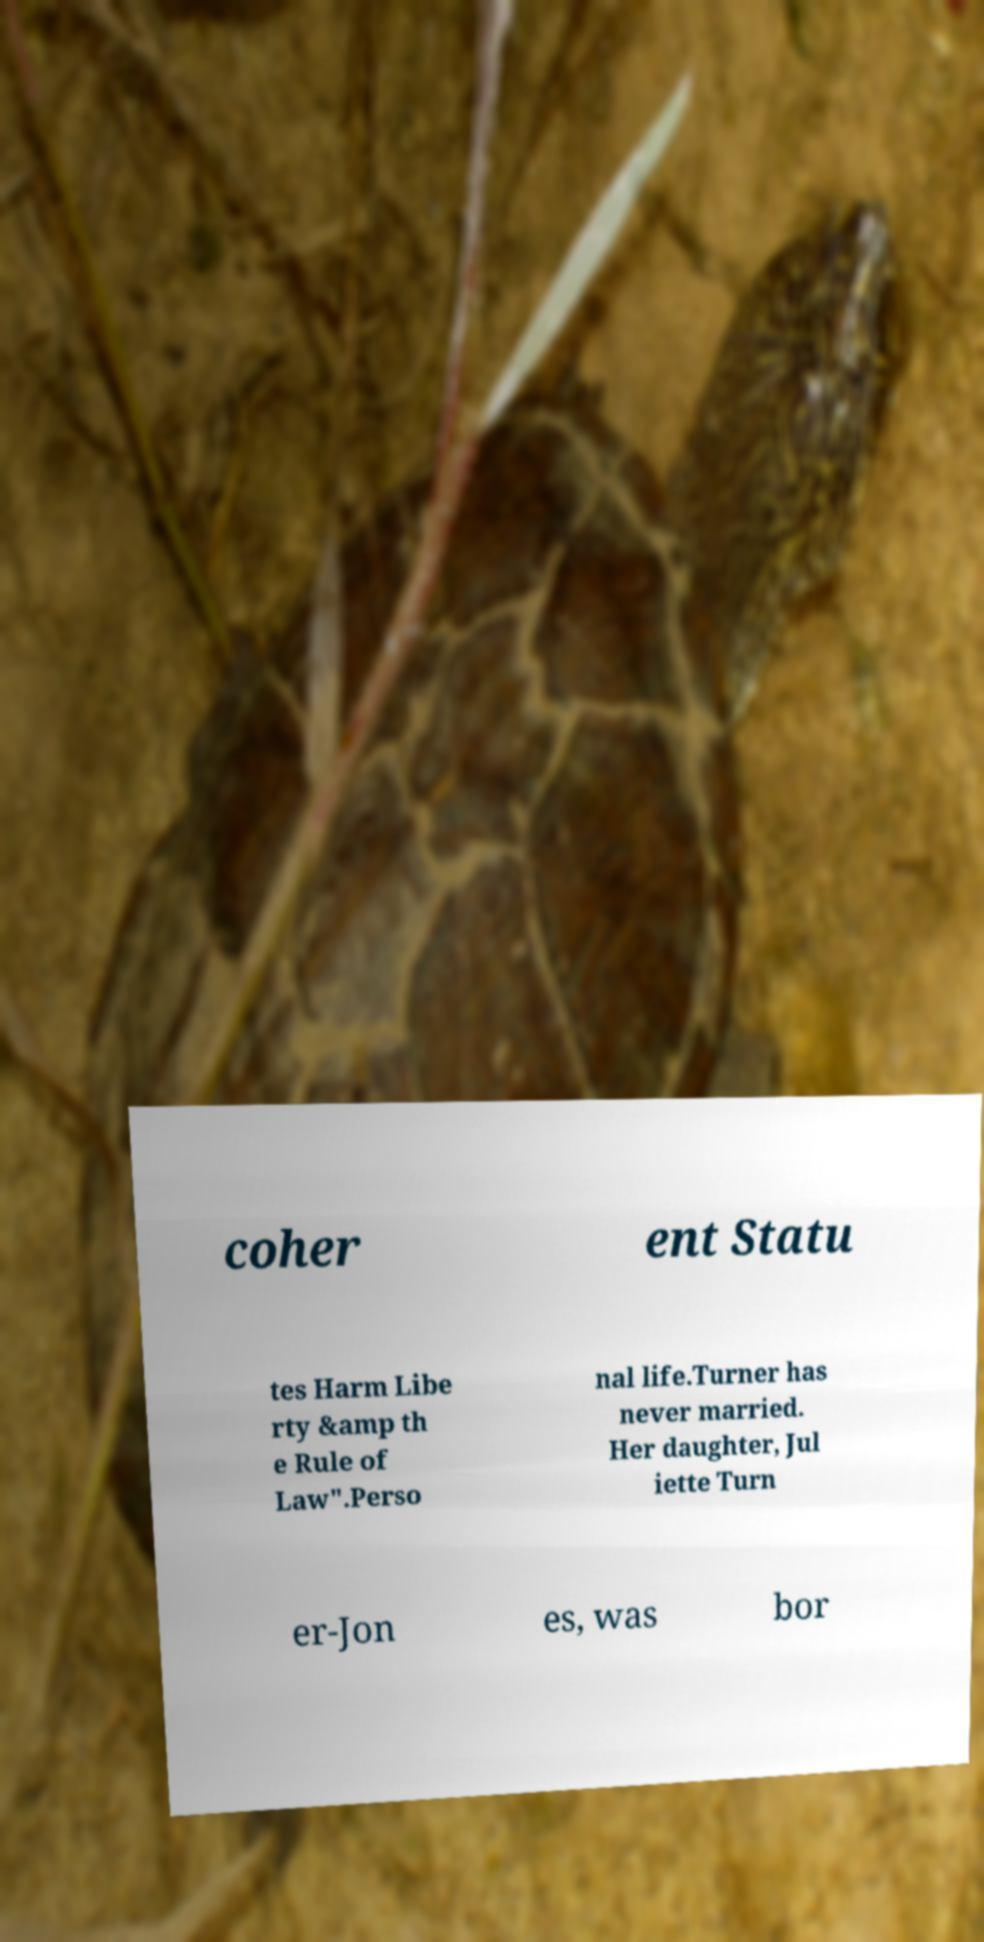Please identify and transcribe the text found in this image. coher ent Statu tes Harm Libe rty &amp th e Rule of Law".Perso nal life.Turner has never married. Her daughter, Jul iette Turn er-Jon es, was bor 